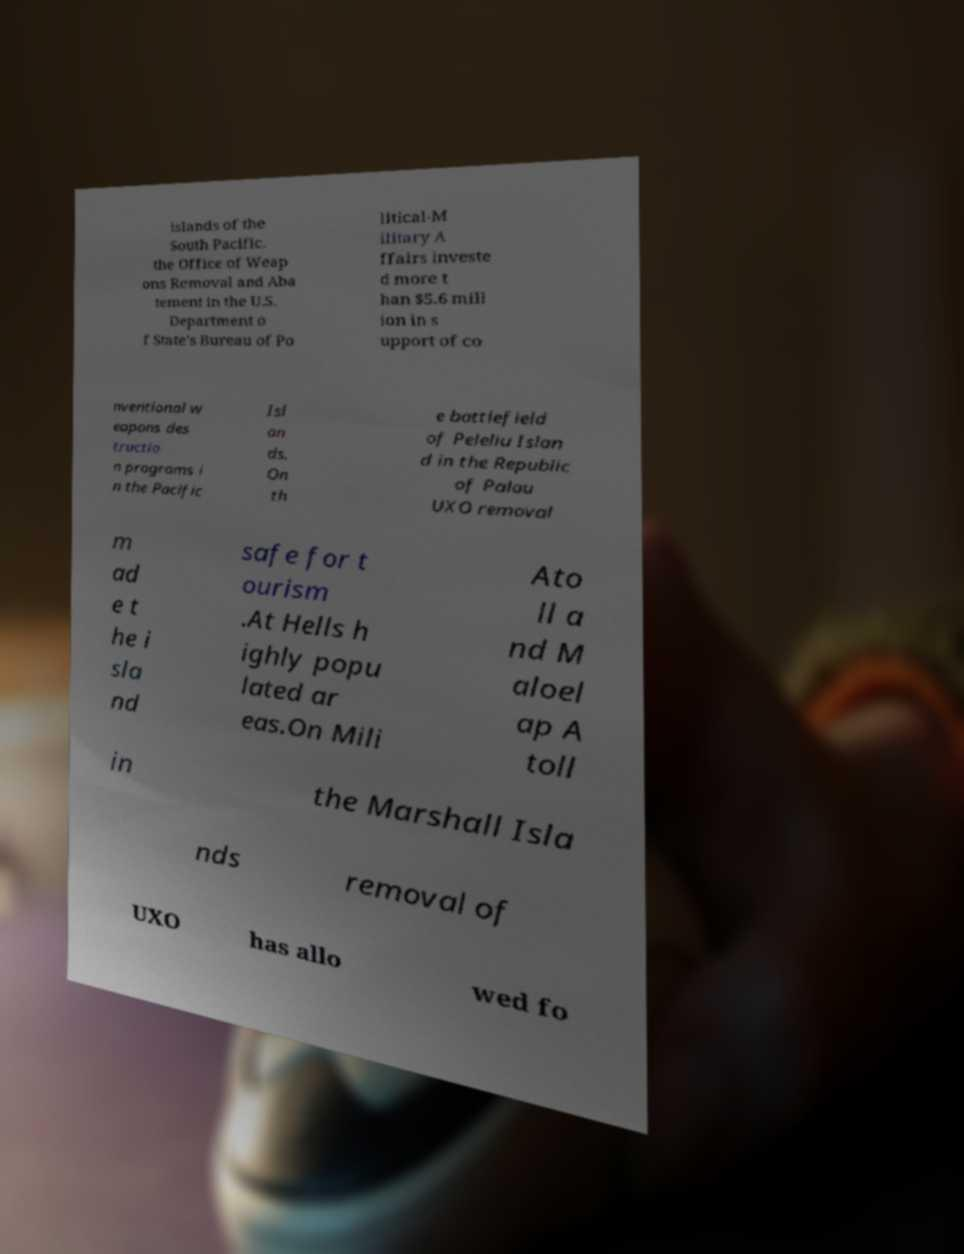Can you read and provide the text displayed in the image?This photo seems to have some interesting text. Can you extract and type it out for me? islands of the South Pacific. the Office of Weap ons Removal and Aba tement in the U.S. Department o f State's Bureau of Po litical-M ilitary A ffairs investe d more t han $5.6 mill ion in s upport of co nventional w eapons des tructio n programs i n the Pacific Isl an ds. On th e battlefield of Peleliu Islan d in the Republic of Palau UXO removal m ad e t he i sla nd safe for t ourism .At Hells h ighly popu lated ar eas.On Mili Ato ll a nd M aloel ap A toll in the Marshall Isla nds removal of UXO has allo wed fo 